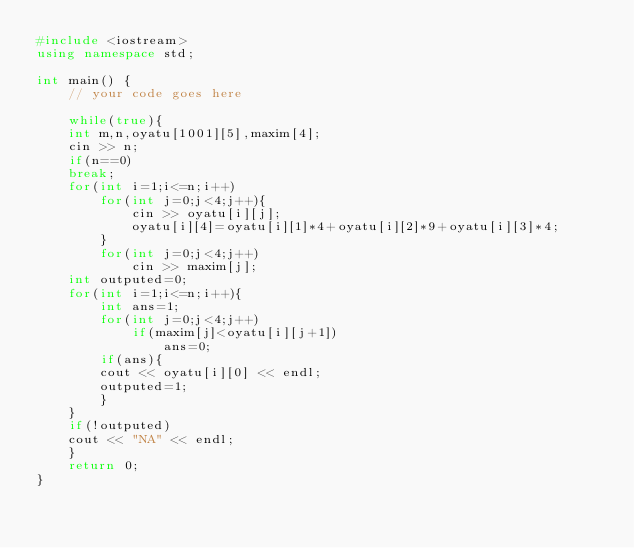<code> <loc_0><loc_0><loc_500><loc_500><_C++_>#include <iostream>
using namespace std;

int main() {
	// your code goes here
	
	while(true){
	int m,n,oyatu[1001][5],maxim[4];
	cin >> n;
	if(n==0)
	break;
	for(int i=1;i<=n;i++)
		for(int j=0;j<4;j++){
			cin >> oyatu[i][j];
			oyatu[i][4]=oyatu[i][1]*4+oyatu[i][2]*9+oyatu[i][3]*4;
		}
		for(int j=0;j<4;j++)
			cin >> maxim[j];
	int outputed=0;
	for(int i=1;i<=n;i++){
		int ans=1;
		for(int j=0;j<4;j++)
			if(maxim[j]<oyatu[i][j+1])
				ans=0;
		if(ans){
		cout << oyatu[i][0] << endl;
		outputed=1;
		}
	}
	if(!outputed)
	cout << "NA" << endl;
	}
	return 0;
}</code> 